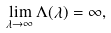<formula> <loc_0><loc_0><loc_500><loc_500>\lim _ { \lambda \to \infty } \Lambda ( \lambda ) = \infty ,</formula> 